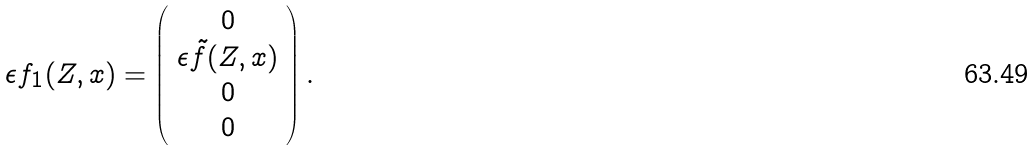<formula> <loc_0><loc_0><loc_500><loc_500>\epsilon f _ { 1 } ( Z , x ) = \left ( \begin{array} { c } 0 \\ \epsilon \tilde { f } ( Z , x ) \\ 0 \\ 0 \end{array} \right ) .</formula> 